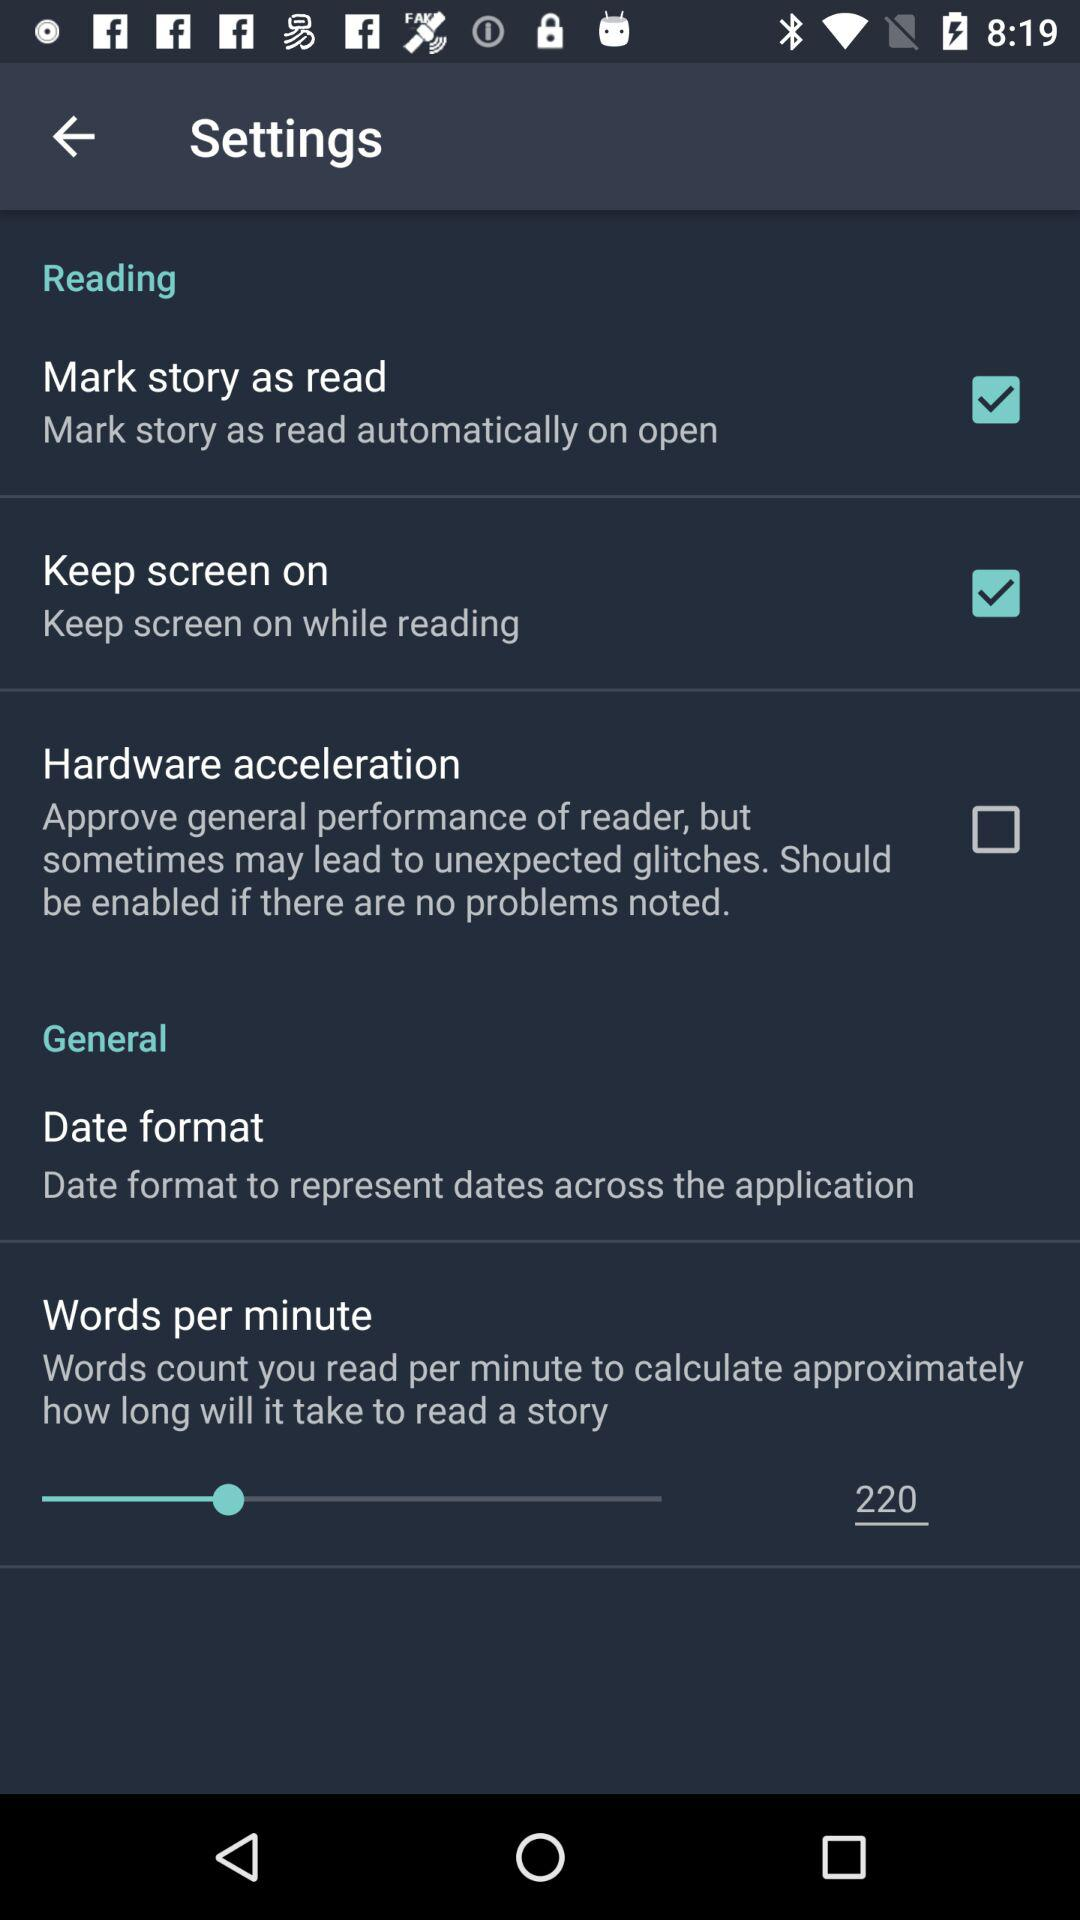How many of the settings are about the reader?
Answer the question using a single word or phrase. 3 